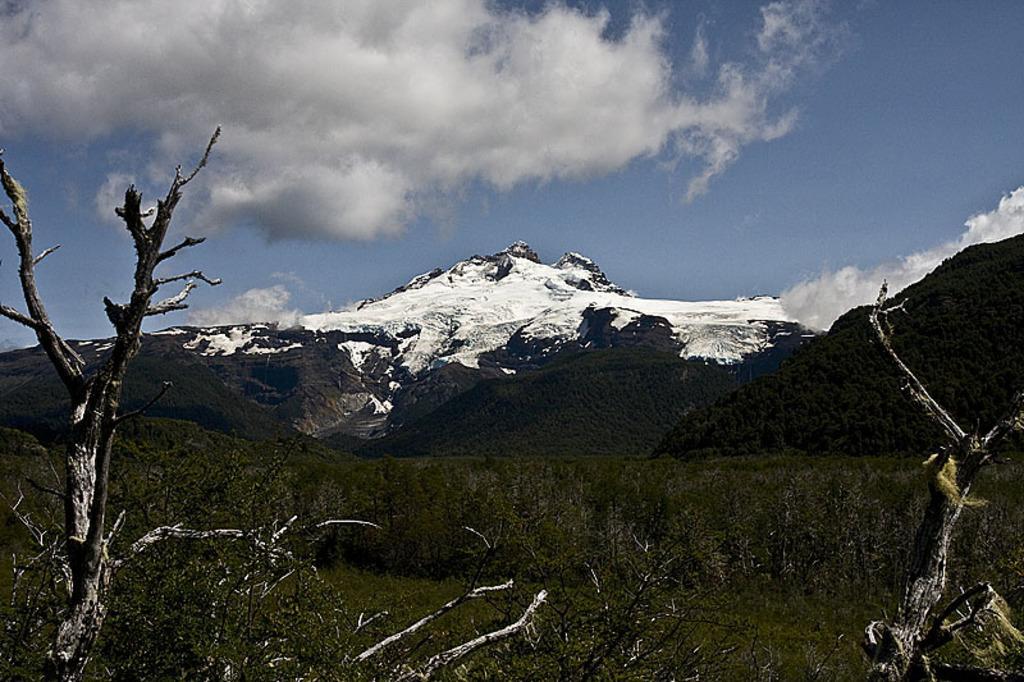How would you summarize this image in a sentence or two? In this picture there are mountains and trees. At the top there is sky and there are clouds. At the bottom there are plants and there is grass. 